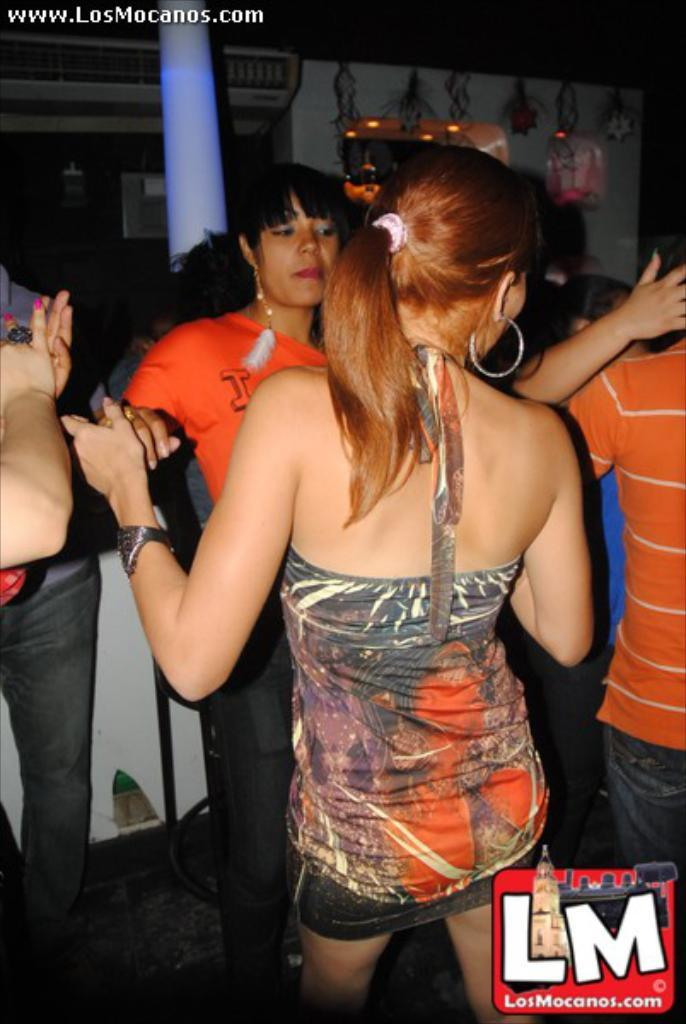What is happening in the image? There are people standing in the image. Can you describe any additional features of the image? There are watermarks in the image, one in the left top corner and another in the right bottom corner. How many apples are on the table in the image? There is no table or apples present in the image. What season is depicted in the image? The provided facts do not mention any season or weather-related details, so it cannot be determined from the image. 